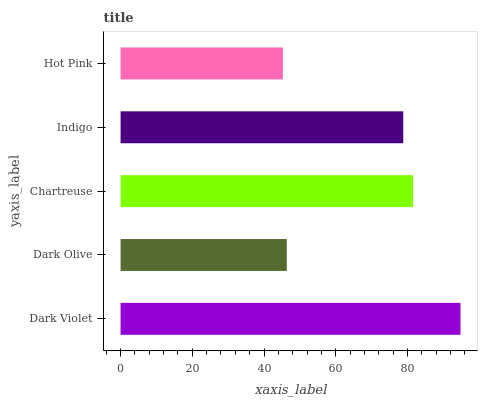Is Hot Pink the minimum?
Answer yes or no. Yes. Is Dark Violet the maximum?
Answer yes or no. Yes. Is Dark Olive the minimum?
Answer yes or no. No. Is Dark Olive the maximum?
Answer yes or no. No. Is Dark Violet greater than Dark Olive?
Answer yes or no. Yes. Is Dark Olive less than Dark Violet?
Answer yes or no. Yes. Is Dark Olive greater than Dark Violet?
Answer yes or no. No. Is Dark Violet less than Dark Olive?
Answer yes or no. No. Is Indigo the high median?
Answer yes or no. Yes. Is Indigo the low median?
Answer yes or no. Yes. Is Dark Violet the high median?
Answer yes or no. No. Is Hot Pink the low median?
Answer yes or no. No. 